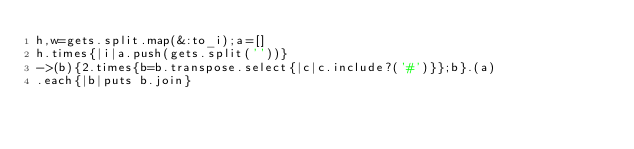Convert code to text. <code><loc_0><loc_0><loc_500><loc_500><_Ruby_>h,w=gets.split.map(&:to_i);a=[]
h.times{|i|a.push(gets.split(''))}
->(b){2.times{b=b.transpose.select{|c|c.include?('#')}};b}.(a)
.each{|b|puts b.join}</code> 